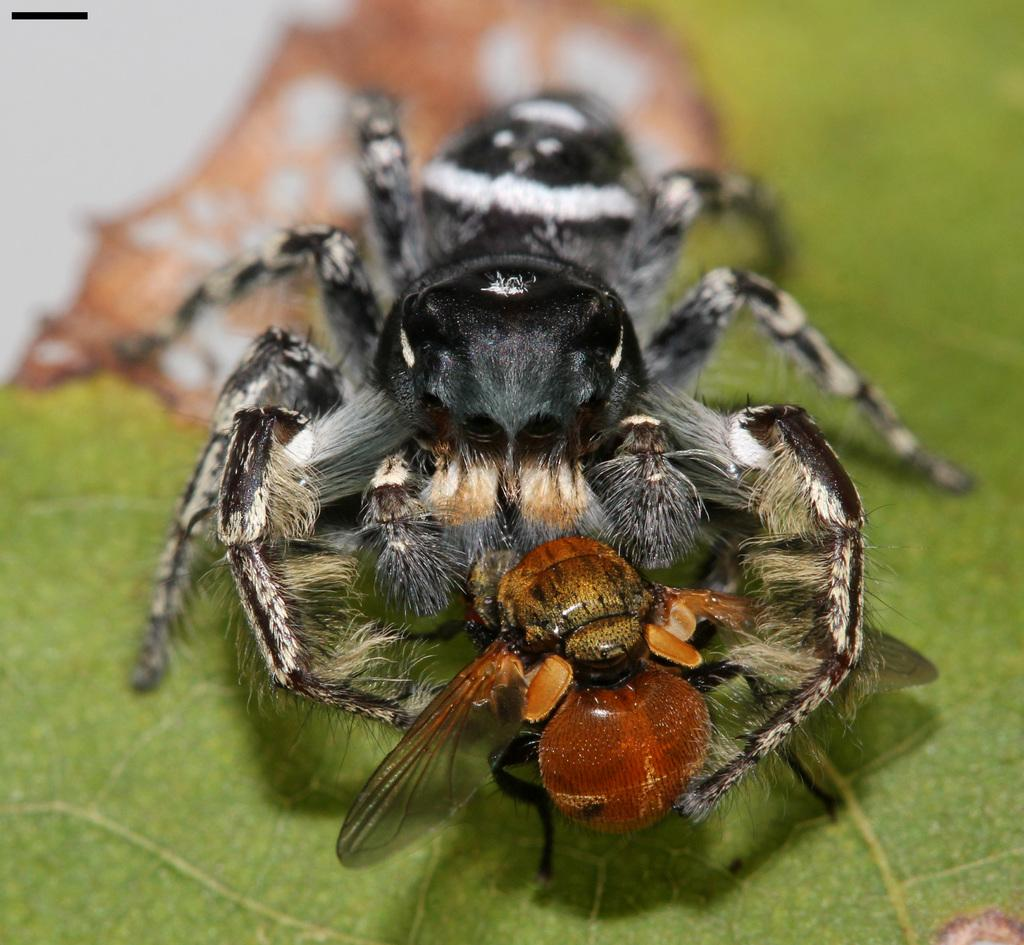What type of creature can be seen in the image? There is an insect in the image. Where is the insect located? The insect is on a leaf. What type of quilt is the insect wearing in the image? There is no quilt or clothing present in the image; the insect is on a leaf. 